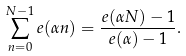Convert formula to latex. <formula><loc_0><loc_0><loc_500><loc_500>\sum _ { n = 0 } ^ { N - 1 } e ( \alpha n ) = \frac { e ( \alpha N ) - 1 } { e ( \alpha ) - 1 } .</formula> 